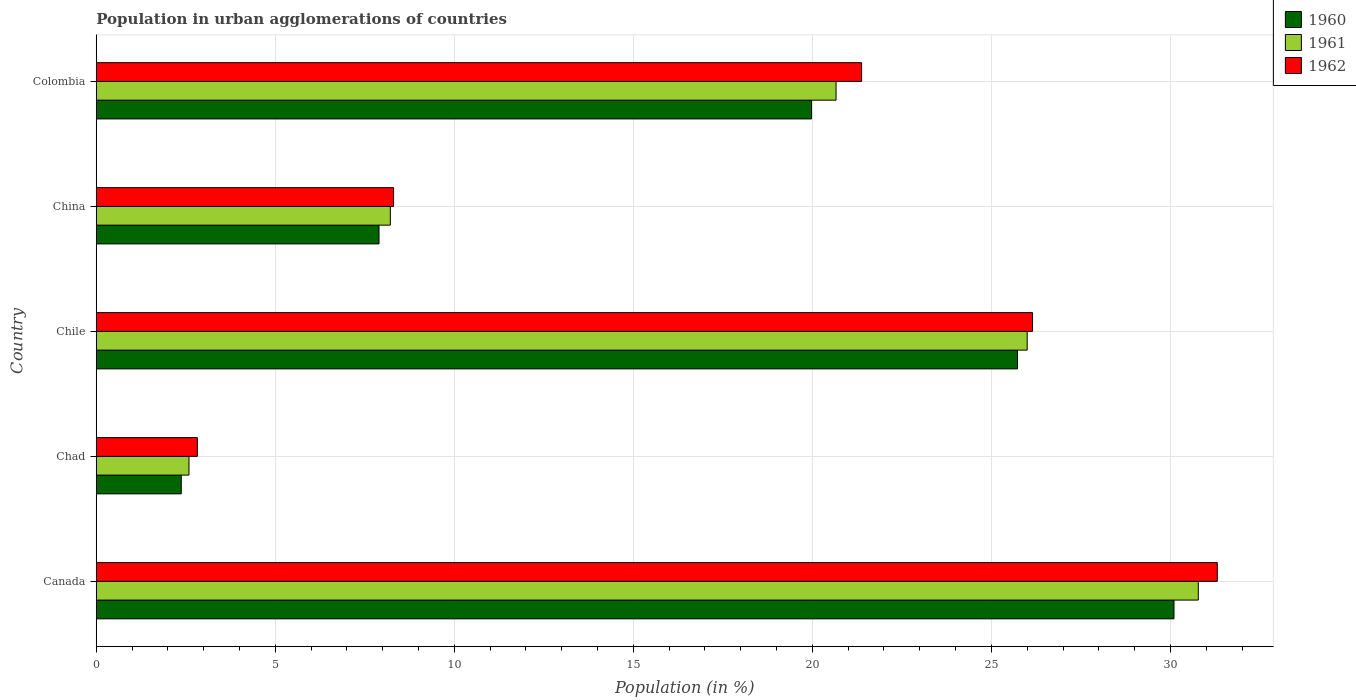How many different coloured bars are there?
Your response must be concise. 3. How many groups of bars are there?
Keep it short and to the point. 5. Are the number of bars per tick equal to the number of legend labels?
Your answer should be compact. Yes. How many bars are there on the 4th tick from the bottom?
Give a very brief answer. 3. What is the percentage of population in urban agglomerations in 1962 in Colombia?
Your answer should be very brief. 21.37. Across all countries, what is the maximum percentage of population in urban agglomerations in 1961?
Offer a terse response. 30.78. Across all countries, what is the minimum percentage of population in urban agglomerations in 1962?
Your response must be concise. 2.82. In which country was the percentage of population in urban agglomerations in 1960 maximum?
Offer a very short reply. Canada. In which country was the percentage of population in urban agglomerations in 1962 minimum?
Keep it short and to the point. Chad. What is the total percentage of population in urban agglomerations in 1962 in the graph?
Offer a very short reply. 89.96. What is the difference between the percentage of population in urban agglomerations in 1962 in Canada and that in Chile?
Provide a succinct answer. 5.16. What is the difference between the percentage of population in urban agglomerations in 1962 in Canada and the percentage of population in urban agglomerations in 1960 in Colombia?
Offer a very short reply. 11.33. What is the average percentage of population in urban agglomerations in 1962 per country?
Ensure brevity in your answer.  17.99. What is the difference between the percentage of population in urban agglomerations in 1962 and percentage of population in urban agglomerations in 1960 in Chad?
Ensure brevity in your answer.  0.45. What is the ratio of the percentage of population in urban agglomerations in 1962 in China to that in Colombia?
Give a very brief answer. 0.39. Is the percentage of population in urban agglomerations in 1961 in Canada less than that in Colombia?
Give a very brief answer. No. What is the difference between the highest and the second highest percentage of population in urban agglomerations in 1962?
Provide a short and direct response. 5.16. What is the difference between the highest and the lowest percentage of population in urban agglomerations in 1960?
Offer a very short reply. 27.72. Is it the case that in every country, the sum of the percentage of population in urban agglomerations in 1962 and percentage of population in urban agglomerations in 1960 is greater than the percentage of population in urban agglomerations in 1961?
Provide a short and direct response. Yes. What is the difference between two consecutive major ticks on the X-axis?
Your response must be concise. 5. Are the values on the major ticks of X-axis written in scientific E-notation?
Provide a short and direct response. No. Does the graph contain any zero values?
Give a very brief answer. No. Does the graph contain grids?
Keep it short and to the point. Yes. How are the legend labels stacked?
Your answer should be compact. Vertical. What is the title of the graph?
Keep it short and to the point. Population in urban agglomerations of countries. What is the Population (in %) of 1960 in Canada?
Provide a succinct answer. 30.1. What is the Population (in %) of 1961 in Canada?
Your answer should be compact. 30.78. What is the Population (in %) in 1962 in Canada?
Your response must be concise. 31.31. What is the Population (in %) in 1960 in Chad?
Provide a short and direct response. 2.37. What is the Population (in %) of 1961 in Chad?
Offer a terse response. 2.59. What is the Population (in %) in 1962 in Chad?
Your answer should be compact. 2.82. What is the Population (in %) of 1960 in Chile?
Provide a short and direct response. 25.73. What is the Population (in %) of 1961 in Chile?
Offer a terse response. 26. What is the Population (in %) of 1962 in Chile?
Provide a short and direct response. 26.15. What is the Population (in %) of 1960 in China?
Your answer should be compact. 7.9. What is the Population (in %) in 1961 in China?
Make the answer very short. 8.21. What is the Population (in %) of 1962 in China?
Keep it short and to the point. 8.3. What is the Population (in %) of 1960 in Colombia?
Your answer should be compact. 19.98. What is the Population (in %) in 1961 in Colombia?
Offer a terse response. 20.66. What is the Population (in %) in 1962 in Colombia?
Make the answer very short. 21.37. Across all countries, what is the maximum Population (in %) of 1960?
Provide a short and direct response. 30.1. Across all countries, what is the maximum Population (in %) of 1961?
Provide a short and direct response. 30.78. Across all countries, what is the maximum Population (in %) of 1962?
Make the answer very short. 31.31. Across all countries, what is the minimum Population (in %) of 1960?
Ensure brevity in your answer.  2.37. Across all countries, what is the minimum Population (in %) in 1961?
Keep it short and to the point. 2.59. Across all countries, what is the minimum Population (in %) in 1962?
Provide a succinct answer. 2.82. What is the total Population (in %) of 1960 in the graph?
Offer a terse response. 86.07. What is the total Population (in %) in 1961 in the graph?
Keep it short and to the point. 88.24. What is the total Population (in %) in 1962 in the graph?
Ensure brevity in your answer.  89.96. What is the difference between the Population (in %) in 1960 in Canada and that in Chad?
Provide a short and direct response. 27.73. What is the difference between the Population (in %) of 1961 in Canada and that in Chad?
Give a very brief answer. 28.19. What is the difference between the Population (in %) in 1962 in Canada and that in Chad?
Provide a succinct answer. 28.49. What is the difference between the Population (in %) of 1960 in Canada and that in Chile?
Ensure brevity in your answer.  4.37. What is the difference between the Population (in %) of 1961 in Canada and that in Chile?
Offer a terse response. 4.78. What is the difference between the Population (in %) in 1962 in Canada and that in Chile?
Your answer should be compact. 5.16. What is the difference between the Population (in %) in 1960 in Canada and that in China?
Give a very brief answer. 22.2. What is the difference between the Population (in %) of 1961 in Canada and that in China?
Your answer should be compact. 22.56. What is the difference between the Population (in %) in 1962 in Canada and that in China?
Keep it short and to the point. 23.01. What is the difference between the Population (in %) of 1960 in Canada and that in Colombia?
Your answer should be compact. 10.12. What is the difference between the Population (in %) in 1961 in Canada and that in Colombia?
Provide a short and direct response. 10.12. What is the difference between the Population (in %) in 1962 in Canada and that in Colombia?
Ensure brevity in your answer.  9.94. What is the difference between the Population (in %) of 1960 in Chad and that in Chile?
Provide a short and direct response. -23.35. What is the difference between the Population (in %) of 1961 in Chad and that in Chile?
Make the answer very short. -23.41. What is the difference between the Population (in %) of 1962 in Chad and that in Chile?
Give a very brief answer. -23.33. What is the difference between the Population (in %) in 1960 in Chad and that in China?
Make the answer very short. -5.52. What is the difference between the Population (in %) in 1961 in Chad and that in China?
Your answer should be compact. -5.62. What is the difference between the Population (in %) in 1962 in Chad and that in China?
Provide a succinct answer. -5.48. What is the difference between the Population (in %) of 1960 in Chad and that in Colombia?
Provide a succinct answer. -17.6. What is the difference between the Population (in %) in 1961 in Chad and that in Colombia?
Provide a short and direct response. -18.07. What is the difference between the Population (in %) of 1962 in Chad and that in Colombia?
Offer a terse response. -18.55. What is the difference between the Population (in %) in 1960 in Chile and that in China?
Give a very brief answer. 17.83. What is the difference between the Population (in %) in 1961 in Chile and that in China?
Your answer should be very brief. 17.79. What is the difference between the Population (in %) of 1962 in Chile and that in China?
Give a very brief answer. 17.85. What is the difference between the Population (in %) of 1960 in Chile and that in Colombia?
Provide a short and direct response. 5.75. What is the difference between the Population (in %) in 1961 in Chile and that in Colombia?
Offer a very short reply. 5.34. What is the difference between the Population (in %) of 1962 in Chile and that in Colombia?
Give a very brief answer. 4.77. What is the difference between the Population (in %) in 1960 in China and that in Colombia?
Keep it short and to the point. -12.08. What is the difference between the Population (in %) of 1961 in China and that in Colombia?
Offer a very short reply. -12.45. What is the difference between the Population (in %) in 1962 in China and that in Colombia?
Give a very brief answer. -13.07. What is the difference between the Population (in %) of 1960 in Canada and the Population (in %) of 1961 in Chad?
Provide a short and direct response. 27.51. What is the difference between the Population (in %) of 1960 in Canada and the Population (in %) of 1962 in Chad?
Provide a short and direct response. 27.28. What is the difference between the Population (in %) of 1961 in Canada and the Population (in %) of 1962 in Chad?
Give a very brief answer. 27.95. What is the difference between the Population (in %) of 1960 in Canada and the Population (in %) of 1961 in Chile?
Your response must be concise. 4.1. What is the difference between the Population (in %) in 1960 in Canada and the Population (in %) in 1962 in Chile?
Keep it short and to the point. 3.95. What is the difference between the Population (in %) in 1961 in Canada and the Population (in %) in 1962 in Chile?
Give a very brief answer. 4.63. What is the difference between the Population (in %) in 1960 in Canada and the Population (in %) in 1961 in China?
Your answer should be very brief. 21.89. What is the difference between the Population (in %) of 1960 in Canada and the Population (in %) of 1962 in China?
Make the answer very short. 21.8. What is the difference between the Population (in %) in 1961 in Canada and the Population (in %) in 1962 in China?
Make the answer very short. 22.47. What is the difference between the Population (in %) of 1960 in Canada and the Population (in %) of 1961 in Colombia?
Your answer should be very brief. 9.44. What is the difference between the Population (in %) of 1960 in Canada and the Population (in %) of 1962 in Colombia?
Provide a short and direct response. 8.73. What is the difference between the Population (in %) in 1961 in Canada and the Population (in %) in 1962 in Colombia?
Your answer should be compact. 9.4. What is the difference between the Population (in %) in 1960 in Chad and the Population (in %) in 1961 in Chile?
Provide a succinct answer. -23.63. What is the difference between the Population (in %) of 1960 in Chad and the Population (in %) of 1962 in Chile?
Offer a very short reply. -23.77. What is the difference between the Population (in %) of 1961 in Chad and the Population (in %) of 1962 in Chile?
Ensure brevity in your answer.  -23.56. What is the difference between the Population (in %) of 1960 in Chad and the Population (in %) of 1961 in China?
Give a very brief answer. -5.84. What is the difference between the Population (in %) of 1960 in Chad and the Population (in %) of 1962 in China?
Give a very brief answer. -5.93. What is the difference between the Population (in %) in 1961 in Chad and the Population (in %) in 1962 in China?
Keep it short and to the point. -5.71. What is the difference between the Population (in %) of 1960 in Chad and the Population (in %) of 1961 in Colombia?
Provide a short and direct response. -18.29. What is the difference between the Population (in %) of 1960 in Chad and the Population (in %) of 1962 in Colombia?
Ensure brevity in your answer.  -19. What is the difference between the Population (in %) in 1961 in Chad and the Population (in %) in 1962 in Colombia?
Your response must be concise. -18.78. What is the difference between the Population (in %) of 1960 in Chile and the Population (in %) of 1961 in China?
Keep it short and to the point. 17.51. What is the difference between the Population (in %) of 1960 in Chile and the Population (in %) of 1962 in China?
Provide a succinct answer. 17.42. What is the difference between the Population (in %) of 1961 in Chile and the Population (in %) of 1962 in China?
Provide a short and direct response. 17.7. What is the difference between the Population (in %) in 1960 in Chile and the Population (in %) in 1961 in Colombia?
Make the answer very short. 5.07. What is the difference between the Population (in %) of 1960 in Chile and the Population (in %) of 1962 in Colombia?
Keep it short and to the point. 4.35. What is the difference between the Population (in %) of 1961 in Chile and the Population (in %) of 1962 in Colombia?
Offer a terse response. 4.63. What is the difference between the Population (in %) of 1960 in China and the Population (in %) of 1961 in Colombia?
Your answer should be compact. -12.76. What is the difference between the Population (in %) in 1960 in China and the Population (in %) in 1962 in Colombia?
Your response must be concise. -13.48. What is the difference between the Population (in %) in 1961 in China and the Population (in %) in 1962 in Colombia?
Give a very brief answer. -13.16. What is the average Population (in %) in 1960 per country?
Offer a very short reply. 17.21. What is the average Population (in %) in 1961 per country?
Offer a terse response. 17.65. What is the average Population (in %) in 1962 per country?
Your answer should be compact. 17.99. What is the difference between the Population (in %) in 1960 and Population (in %) in 1961 in Canada?
Give a very brief answer. -0.68. What is the difference between the Population (in %) of 1960 and Population (in %) of 1962 in Canada?
Give a very brief answer. -1.21. What is the difference between the Population (in %) in 1961 and Population (in %) in 1962 in Canada?
Provide a short and direct response. -0.53. What is the difference between the Population (in %) of 1960 and Population (in %) of 1961 in Chad?
Your response must be concise. -0.22. What is the difference between the Population (in %) in 1960 and Population (in %) in 1962 in Chad?
Make the answer very short. -0.45. What is the difference between the Population (in %) in 1961 and Population (in %) in 1962 in Chad?
Offer a very short reply. -0.23. What is the difference between the Population (in %) in 1960 and Population (in %) in 1961 in Chile?
Provide a short and direct response. -0.27. What is the difference between the Population (in %) of 1960 and Population (in %) of 1962 in Chile?
Your response must be concise. -0.42. What is the difference between the Population (in %) in 1961 and Population (in %) in 1962 in Chile?
Your answer should be very brief. -0.15. What is the difference between the Population (in %) in 1960 and Population (in %) in 1961 in China?
Offer a very short reply. -0.32. What is the difference between the Population (in %) in 1960 and Population (in %) in 1962 in China?
Make the answer very short. -0.41. What is the difference between the Population (in %) of 1961 and Population (in %) of 1962 in China?
Your answer should be compact. -0.09. What is the difference between the Population (in %) of 1960 and Population (in %) of 1961 in Colombia?
Offer a terse response. -0.69. What is the difference between the Population (in %) of 1960 and Population (in %) of 1962 in Colombia?
Make the answer very short. -1.4. What is the difference between the Population (in %) in 1961 and Population (in %) in 1962 in Colombia?
Provide a succinct answer. -0.71. What is the ratio of the Population (in %) in 1960 in Canada to that in Chad?
Your answer should be very brief. 12.68. What is the ratio of the Population (in %) of 1961 in Canada to that in Chad?
Offer a terse response. 11.89. What is the ratio of the Population (in %) in 1962 in Canada to that in Chad?
Provide a succinct answer. 11.09. What is the ratio of the Population (in %) in 1960 in Canada to that in Chile?
Provide a succinct answer. 1.17. What is the ratio of the Population (in %) in 1961 in Canada to that in Chile?
Your answer should be very brief. 1.18. What is the ratio of the Population (in %) in 1962 in Canada to that in Chile?
Provide a short and direct response. 1.2. What is the ratio of the Population (in %) of 1960 in Canada to that in China?
Provide a short and direct response. 3.81. What is the ratio of the Population (in %) in 1961 in Canada to that in China?
Your answer should be compact. 3.75. What is the ratio of the Population (in %) in 1962 in Canada to that in China?
Ensure brevity in your answer.  3.77. What is the ratio of the Population (in %) of 1960 in Canada to that in Colombia?
Give a very brief answer. 1.51. What is the ratio of the Population (in %) of 1961 in Canada to that in Colombia?
Your answer should be very brief. 1.49. What is the ratio of the Population (in %) in 1962 in Canada to that in Colombia?
Your answer should be very brief. 1.46. What is the ratio of the Population (in %) in 1960 in Chad to that in Chile?
Your answer should be very brief. 0.09. What is the ratio of the Population (in %) in 1961 in Chad to that in Chile?
Offer a terse response. 0.1. What is the ratio of the Population (in %) in 1962 in Chad to that in Chile?
Provide a succinct answer. 0.11. What is the ratio of the Population (in %) of 1960 in Chad to that in China?
Ensure brevity in your answer.  0.3. What is the ratio of the Population (in %) in 1961 in Chad to that in China?
Offer a very short reply. 0.32. What is the ratio of the Population (in %) in 1962 in Chad to that in China?
Provide a short and direct response. 0.34. What is the ratio of the Population (in %) of 1960 in Chad to that in Colombia?
Give a very brief answer. 0.12. What is the ratio of the Population (in %) in 1961 in Chad to that in Colombia?
Your answer should be compact. 0.13. What is the ratio of the Population (in %) of 1962 in Chad to that in Colombia?
Make the answer very short. 0.13. What is the ratio of the Population (in %) of 1960 in Chile to that in China?
Ensure brevity in your answer.  3.26. What is the ratio of the Population (in %) in 1961 in Chile to that in China?
Your response must be concise. 3.17. What is the ratio of the Population (in %) in 1962 in Chile to that in China?
Your answer should be compact. 3.15. What is the ratio of the Population (in %) of 1960 in Chile to that in Colombia?
Your response must be concise. 1.29. What is the ratio of the Population (in %) of 1961 in Chile to that in Colombia?
Your answer should be very brief. 1.26. What is the ratio of the Population (in %) in 1962 in Chile to that in Colombia?
Your response must be concise. 1.22. What is the ratio of the Population (in %) in 1960 in China to that in Colombia?
Your answer should be compact. 0.4. What is the ratio of the Population (in %) of 1961 in China to that in Colombia?
Keep it short and to the point. 0.4. What is the ratio of the Population (in %) of 1962 in China to that in Colombia?
Offer a very short reply. 0.39. What is the difference between the highest and the second highest Population (in %) of 1960?
Offer a very short reply. 4.37. What is the difference between the highest and the second highest Population (in %) in 1961?
Keep it short and to the point. 4.78. What is the difference between the highest and the second highest Population (in %) of 1962?
Offer a very short reply. 5.16. What is the difference between the highest and the lowest Population (in %) in 1960?
Offer a very short reply. 27.73. What is the difference between the highest and the lowest Population (in %) of 1961?
Make the answer very short. 28.19. What is the difference between the highest and the lowest Population (in %) of 1962?
Make the answer very short. 28.49. 